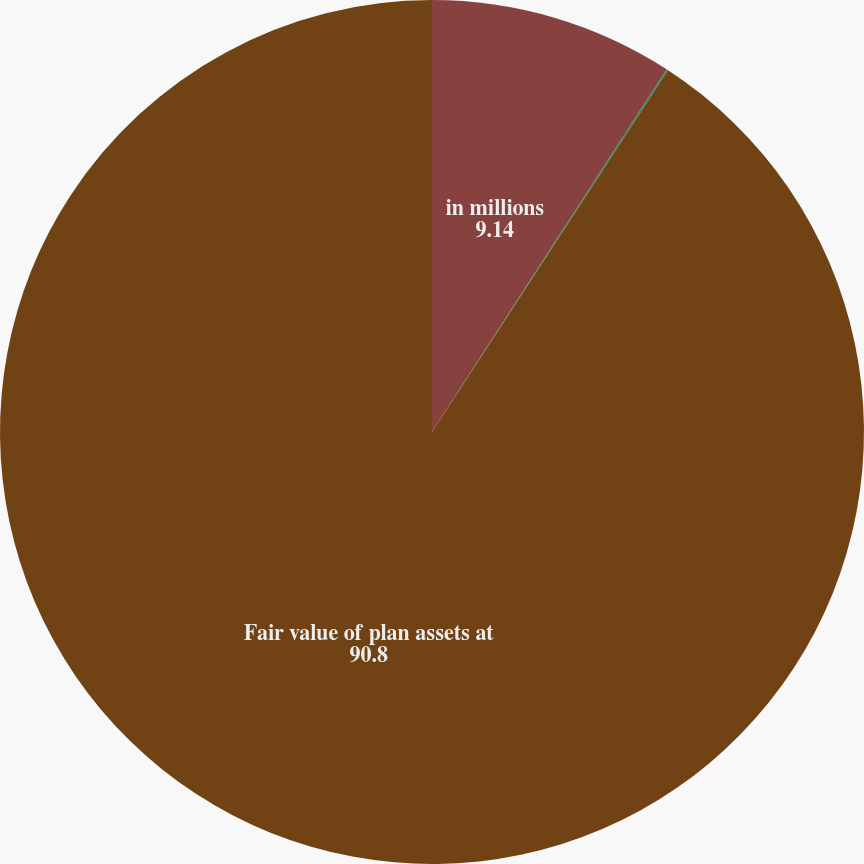Convert chart to OTSL. <chart><loc_0><loc_0><loc_500><loc_500><pie_chart><fcel>in millions<fcel>Other Assets<fcel>Fair value of plan assets at<nl><fcel>9.14%<fcel>0.06%<fcel>90.8%<nl></chart> 